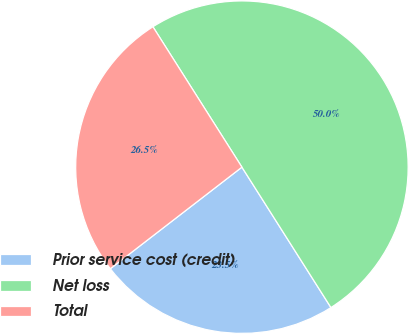Convert chart. <chart><loc_0><loc_0><loc_500><loc_500><pie_chart><fcel>Prior service cost (credit)<fcel>Net loss<fcel>Total<nl><fcel>23.53%<fcel>50.0%<fcel>26.47%<nl></chart> 